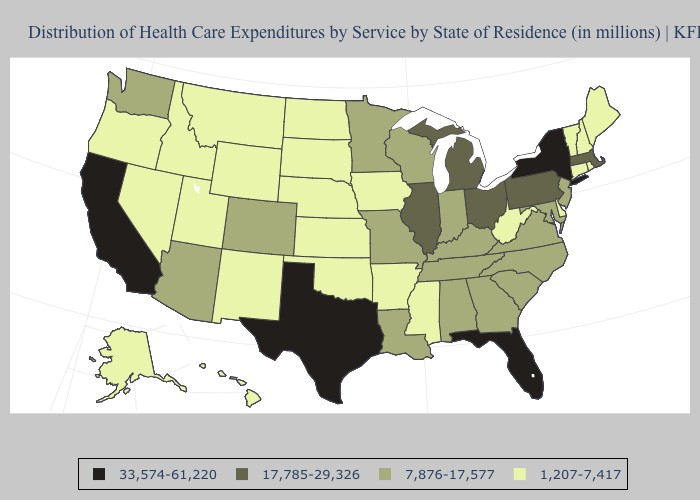Does New Hampshire have the lowest value in the USA?
Short answer required. Yes. What is the value of Delaware?
Write a very short answer. 1,207-7,417. Among the states that border Texas , which have the lowest value?
Answer briefly. Arkansas, New Mexico, Oklahoma. What is the lowest value in states that border Minnesota?
Write a very short answer. 1,207-7,417. What is the value of Pennsylvania?
Give a very brief answer. 17,785-29,326. What is the value of Florida?
Give a very brief answer. 33,574-61,220. What is the value of Delaware?
Quick response, please. 1,207-7,417. Name the states that have a value in the range 17,785-29,326?
Write a very short answer. Illinois, Massachusetts, Michigan, Ohio, Pennsylvania. What is the highest value in states that border Pennsylvania?
Be succinct. 33,574-61,220. Among the states that border Colorado , does Arizona have the highest value?
Quick response, please. Yes. What is the highest value in states that border Massachusetts?
Keep it brief. 33,574-61,220. Name the states that have a value in the range 33,574-61,220?
Short answer required. California, Florida, New York, Texas. Name the states that have a value in the range 33,574-61,220?
Write a very short answer. California, Florida, New York, Texas. Does Ohio have the highest value in the MidWest?
Concise answer only. Yes. 